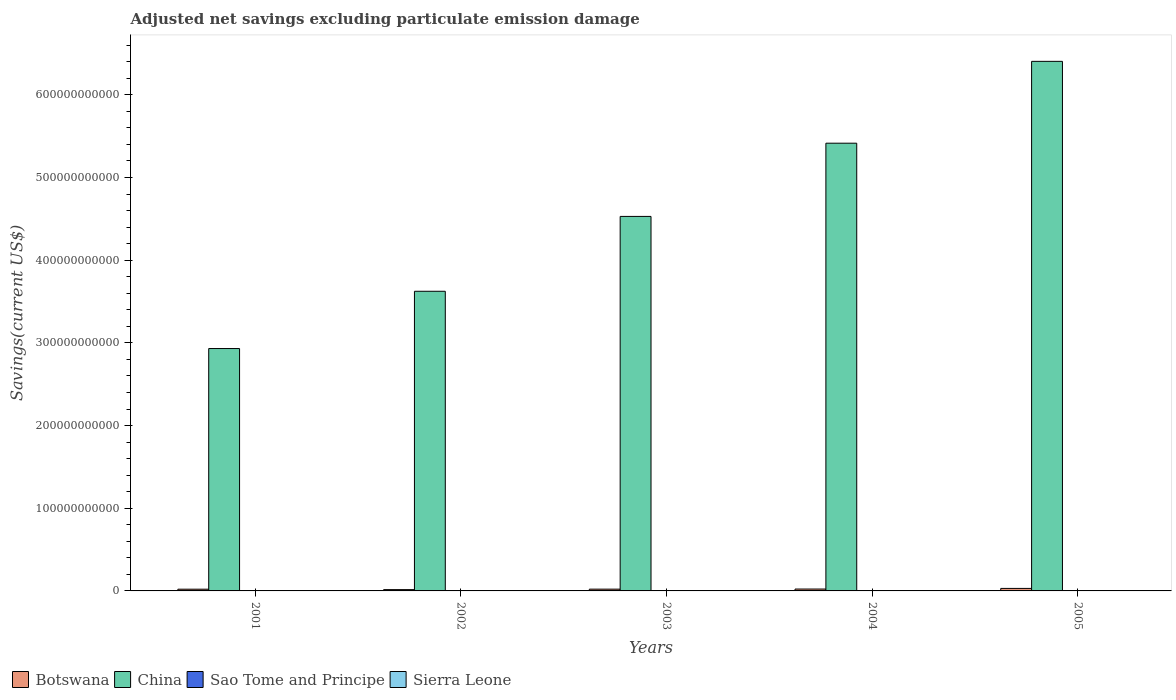How many groups of bars are there?
Your response must be concise. 5. Are the number of bars per tick equal to the number of legend labels?
Keep it short and to the point. No. How many bars are there on the 5th tick from the right?
Ensure brevity in your answer.  2. In how many cases, is the number of bars for a given year not equal to the number of legend labels?
Your response must be concise. 5. What is the adjusted net savings in Botswana in 2004?
Offer a very short reply. 2.28e+09. Across all years, what is the maximum adjusted net savings in China?
Your answer should be compact. 6.41e+11. Across all years, what is the minimum adjusted net savings in Sierra Leone?
Your response must be concise. 0. In which year was the adjusted net savings in Botswana maximum?
Your answer should be very brief. 2005. What is the total adjusted net savings in Sao Tome and Principe in the graph?
Ensure brevity in your answer.  4.16e+07. What is the difference between the adjusted net savings in Botswana in 2001 and that in 2004?
Ensure brevity in your answer.  -2.01e+08. What is the difference between the adjusted net savings in Botswana in 2005 and the adjusted net savings in Sao Tome and Principe in 2001?
Give a very brief answer. 3.02e+09. In the year 2005, what is the difference between the adjusted net savings in Sao Tome and Principe and adjusted net savings in China?
Make the answer very short. -6.40e+11. What is the ratio of the adjusted net savings in China in 2003 to that in 2004?
Your answer should be compact. 0.84. Is the adjusted net savings in China in 2002 less than that in 2004?
Your answer should be compact. Yes. What is the difference between the highest and the second highest adjusted net savings in Botswana?
Make the answer very short. 7.42e+08. What is the difference between the highest and the lowest adjusted net savings in Botswana?
Your response must be concise. 1.44e+09. In how many years, is the adjusted net savings in Sierra Leone greater than the average adjusted net savings in Sierra Leone taken over all years?
Offer a terse response. 0. Is the sum of the adjusted net savings in China in 2004 and 2005 greater than the maximum adjusted net savings in Sao Tome and Principe across all years?
Keep it short and to the point. Yes. Is it the case that in every year, the sum of the adjusted net savings in Botswana and adjusted net savings in China is greater than the sum of adjusted net savings in Sao Tome and Principe and adjusted net savings in Sierra Leone?
Make the answer very short. No. What is the difference between two consecutive major ticks on the Y-axis?
Offer a very short reply. 1.00e+11. Are the values on the major ticks of Y-axis written in scientific E-notation?
Your response must be concise. No. Where does the legend appear in the graph?
Offer a terse response. Bottom left. What is the title of the graph?
Ensure brevity in your answer.  Adjusted net savings excluding particulate emission damage. Does "Iraq" appear as one of the legend labels in the graph?
Make the answer very short. No. What is the label or title of the Y-axis?
Offer a terse response. Savings(current US$). What is the Savings(current US$) in Botswana in 2001?
Your answer should be compact. 2.08e+09. What is the Savings(current US$) of China in 2001?
Provide a short and direct response. 2.93e+11. What is the Savings(current US$) of Botswana in 2002?
Your response must be concise. 1.58e+09. What is the Savings(current US$) of China in 2002?
Offer a terse response. 3.62e+11. What is the Savings(current US$) of Sierra Leone in 2002?
Give a very brief answer. 0. What is the Savings(current US$) of Botswana in 2003?
Your response must be concise. 2.15e+09. What is the Savings(current US$) in China in 2003?
Keep it short and to the point. 4.53e+11. What is the Savings(current US$) in Sierra Leone in 2003?
Your answer should be very brief. 0. What is the Savings(current US$) in Botswana in 2004?
Offer a terse response. 2.28e+09. What is the Savings(current US$) of China in 2004?
Provide a short and direct response. 5.42e+11. What is the Savings(current US$) of Botswana in 2005?
Provide a succinct answer. 3.02e+09. What is the Savings(current US$) of China in 2005?
Ensure brevity in your answer.  6.41e+11. What is the Savings(current US$) in Sao Tome and Principe in 2005?
Ensure brevity in your answer.  4.16e+07. Across all years, what is the maximum Savings(current US$) in Botswana?
Give a very brief answer. 3.02e+09. Across all years, what is the maximum Savings(current US$) of China?
Offer a terse response. 6.41e+11. Across all years, what is the maximum Savings(current US$) in Sao Tome and Principe?
Make the answer very short. 4.16e+07. Across all years, what is the minimum Savings(current US$) of Botswana?
Your response must be concise. 1.58e+09. Across all years, what is the minimum Savings(current US$) in China?
Provide a short and direct response. 2.93e+11. Across all years, what is the minimum Savings(current US$) of Sao Tome and Principe?
Make the answer very short. 0. What is the total Savings(current US$) of Botswana in the graph?
Provide a succinct answer. 1.11e+1. What is the total Savings(current US$) in China in the graph?
Provide a succinct answer. 2.29e+12. What is the total Savings(current US$) of Sao Tome and Principe in the graph?
Your answer should be very brief. 4.16e+07. What is the total Savings(current US$) in Sierra Leone in the graph?
Make the answer very short. 0. What is the difference between the Savings(current US$) in Botswana in 2001 and that in 2002?
Offer a very short reply. 4.96e+08. What is the difference between the Savings(current US$) of China in 2001 and that in 2002?
Give a very brief answer. -6.93e+1. What is the difference between the Savings(current US$) in Botswana in 2001 and that in 2003?
Keep it short and to the point. -7.26e+07. What is the difference between the Savings(current US$) of China in 2001 and that in 2003?
Make the answer very short. -1.60e+11. What is the difference between the Savings(current US$) in Botswana in 2001 and that in 2004?
Keep it short and to the point. -2.01e+08. What is the difference between the Savings(current US$) in China in 2001 and that in 2004?
Make the answer very short. -2.48e+11. What is the difference between the Savings(current US$) in Botswana in 2001 and that in 2005?
Keep it short and to the point. -9.43e+08. What is the difference between the Savings(current US$) in China in 2001 and that in 2005?
Ensure brevity in your answer.  -3.47e+11. What is the difference between the Savings(current US$) of Botswana in 2002 and that in 2003?
Give a very brief answer. -5.69e+08. What is the difference between the Savings(current US$) of China in 2002 and that in 2003?
Offer a terse response. -9.05e+1. What is the difference between the Savings(current US$) of Botswana in 2002 and that in 2004?
Offer a terse response. -6.97e+08. What is the difference between the Savings(current US$) of China in 2002 and that in 2004?
Your answer should be compact. -1.79e+11. What is the difference between the Savings(current US$) of Botswana in 2002 and that in 2005?
Make the answer very short. -1.44e+09. What is the difference between the Savings(current US$) in China in 2002 and that in 2005?
Your answer should be very brief. -2.78e+11. What is the difference between the Savings(current US$) of Botswana in 2003 and that in 2004?
Offer a very short reply. -1.28e+08. What is the difference between the Savings(current US$) in China in 2003 and that in 2004?
Make the answer very short. -8.86e+1. What is the difference between the Savings(current US$) in Botswana in 2003 and that in 2005?
Provide a succinct answer. -8.70e+08. What is the difference between the Savings(current US$) of China in 2003 and that in 2005?
Ensure brevity in your answer.  -1.88e+11. What is the difference between the Savings(current US$) in Botswana in 2004 and that in 2005?
Offer a terse response. -7.42e+08. What is the difference between the Savings(current US$) in China in 2004 and that in 2005?
Keep it short and to the point. -9.90e+1. What is the difference between the Savings(current US$) in Botswana in 2001 and the Savings(current US$) in China in 2002?
Your answer should be compact. -3.60e+11. What is the difference between the Savings(current US$) of Botswana in 2001 and the Savings(current US$) of China in 2003?
Your answer should be compact. -4.51e+11. What is the difference between the Savings(current US$) in Botswana in 2001 and the Savings(current US$) in China in 2004?
Offer a very short reply. -5.39e+11. What is the difference between the Savings(current US$) in Botswana in 2001 and the Savings(current US$) in China in 2005?
Your answer should be very brief. -6.38e+11. What is the difference between the Savings(current US$) in Botswana in 2001 and the Savings(current US$) in Sao Tome and Principe in 2005?
Provide a short and direct response. 2.04e+09. What is the difference between the Savings(current US$) in China in 2001 and the Savings(current US$) in Sao Tome and Principe in 2005?
Keep it short and to the point. 2.93e+11. What is the difference between the Savings(current US$) in Botswana in 2002 and the Savings(current US$) in China in 2003?
Offer a very short reply. -4.51e+11. What is the difference between the Savings(current US$) of Botswana in 2002 and the Savings(current US$) of China in 2004?
Offer a terse response. -5.40e+11. What is the difference between the Savings(current US$) of Botswana in 2002 and the Savings(current US$) of China in 2005?
Your response must be concise. -6.39e+11. What is the difference between the Savings(current US$) in Botswana in 2002 and the Savings(current US$) in Sao Tome and Principe in 2005?
Your response must be concise. 1.54e+09. What is the difference between the Savings(current US$) in China in 2002 and the Savings(current US$) in Sao Tome and Principe in 2005?
Make the answer very short. 3.62e+11. What is the difference between the Savings(current US$) of Botswana in 2003 and the Savings(current US$) of China in 2004?
Your response must be concise. -5.39e+11. What is the difference between the Savings(current US$) of Botswana in 2003 and the Savings(current US$) of China in 2005?
Your answer should be compact. -6.38e+11. What is the difference between the Savings(current US$) in Botswana in 2003 and the Savings(current US$) in Sao Tome and Principe in 2005?
Provide a succinct answer. 2.11e+09. What is the difference between the Savings(current US$) of China in 2003 and the Savings(current US$) of Sao Tome and Principe in 2005?
Keep it short and to the point. 4.53e+11. What is the difference between the Savings(current US$) in Botswana in 2004 and the Savings(current US$) in China in 2005?
Offer a very short reply. -6.38e+11. What is the difference between the Savings(current US$) of Botswana in 2004 and the Savings(current US$) of Sao Tome and Principe in 2005?
Give a very brief answer. 2.24e+09. What is the difference between the Savings(current US$) in China in 2004 and the Savings(current US$) in Sao Tome and Principe in 2005?
Offer a terse response. 5.41e+11. What is the average Savings(current US$) of Botswana per year?
Offer a very short reply. 2.22e+09. What is the average Savings(current US$) of China per year?
Keep it short and to the point. 4.58e+11. What is the average Savings(current US$) in Sao Tome and Principe per year?
Provide a succinct answer. 8.32e+06. What is the average Savings(current US$) in Sierra Leone per year?
Your response must be concise. 0. In the year 2001, what is the difference between the Savings(current US$) of Botswana and Savings(current US$) of China?
Provide a short and direct response. -2.91e+11. In the year 2002, what is the difference between the Savings(current US$) of Botswana and Savings(current US$) of China?
Ensure brevity in your answer.  -3.61e+11. In the year 2003, what is the difference between the Savings(current US$) in Botswana and Savings(current US$) in China?
Provide a short and direct response. -4.51e+11. In the year 2004, what is the difference between the Savings(current US$) of Botswana and Savings(current US$) of China?
Provide a succinct answer. -5.39e+11. In the year 2005, what is the difference between the Savings(current US$) of Botswana and Savings(current US$) of China?
Provide a short and direct response. -6.37e+11. In the year 2005, what is the difference between the Savings(current US$) of Botswana and Savings(current US$) of Sao Tome and Principe?
Keep it short and to the point. 2.98e+09. In the year 2005, what is the difference between the Savings(current US$) in China and Savings(current US$) in Sao Tome and Principe?
Keep it short and to the point. 6.40e+11. What is the ratio of the Savings(current US$) in Botswana in 2001 to that in 2002?
Provide a succinct answer. 1.31. What is the ratio of the Savings(current US$) in China in 2001 to that in 2002?
Make the answer very short. 0.81. What is the ratio of the Savings(current US$) in Botswana in 2001 to that in 2003?
Make the answer very short. 0.97. What is the ratio of the Savings(current US$) of China in 2001 to that in 2003?
Your answer should be compact. 0.65. What is the ratio of the Savings(current US$) in Botswana in 2001 to that in 2004?
Your answer should be very brief. 0.91. What is the ratio of the Savings(current US$) in China in 2001 to that in 2004?
Offer a terse response. 0.54. What is the ratio of the Savings(current US$) of Botswana in 2001 to that in 2005?
Your answer should be compact. 0.69. What is the ratio of the Savings(current US$) of China in 2001 to that in 2005?
Your response must be concise. 0.46. What is the ratio of the Savings(current US$) of Botswana in 2002 to that in 2003?
Your answer should be compact. 0.74. What is the ratio of the Savings(current US$) of China in 2002 to that in 2003?
Keep it short and to the point. 0.8. What is the ratio of the Savings(current US$) in Botswana in 2002 to that in 2004?
Offer a very short reply. 0.69. What is the ratio of the Savings(current US$) of China in 2002 to that in 2004?
Your response must be concise. 0.67. What is the ratio of the Savings(current US$) in Botswana in 2002 to that in 2005?
Give a very brief answer. 0.52. What is the ratio of the Savings(current US$) in China in 2002 to that in 2005?
Make the answer very short. 0.57. What is the ratio of the Savings(current US$) of Botswana in 2003 to that in 2004?
Offer a very short reply. 0.94. What is the ratio of the Savings(current US$) in China in 2003 to that in 2004?
Ensure brevity in your answer.  0.84. What is the ratio of the Savings(current US$) in Botswana in 2003 to that in 2005?
Your response must be concise. 0.71. What is the ratio of the Savings(current US$) of China in 2003 to that in 2005?
Ensure brevity in your answer.  0.71. What is the ratio of the Savings(current US$) in Botswana in 2004 to that in 2005?
Give a very brief answer. 0.75. What is the ratio of the Savings(current US$) of China in 2004 to that in 2005?
Offer a very short reply. 0.85. What is the difference between the highest and the second highest Savings(current US$) in Botswana?
Give a very brief answer. 7.42e+08. What is the difference between the highest and the second highest Savings(current US$) of China?
Ensure brevity in your answer.  9.90e+1. What is the difference between the highest and the lowest Savings(current US$) of Botswana?
Offer a terse response. 1.44e+09. What is the difference between the highest and the lowest Savings(current US$) in China?
Your answer should be compact. 3.47e+11. What is the difference between the highest and the lowest Savings(current US$) in Sao Tome and Principe?
Give a very brief answer. 4.16e+07. 